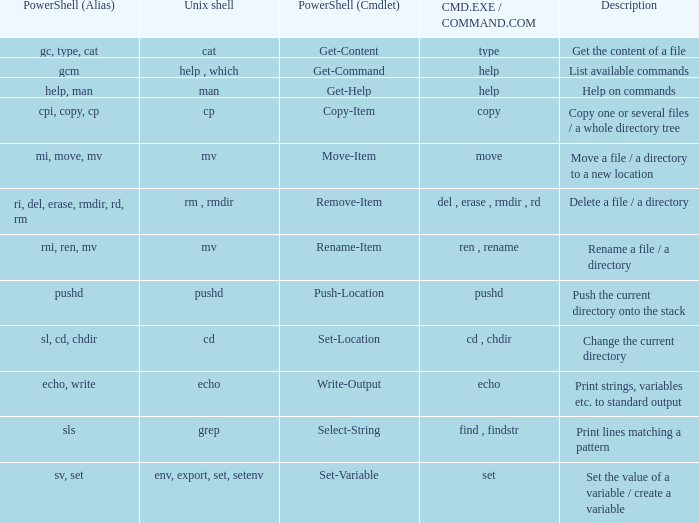When the cmd.exe / command.com is type, what are all associated values for powershell (cmdlet)? Get-Content. 